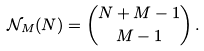<formula> <loc_0><loc_0><loc_500><loc_500>\mathcal { N } _ { M } ( N ) = { N + M - 1 \choose M - 1 } \, .</formula> 